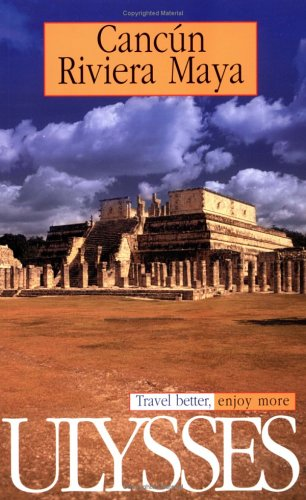Can you describe the historical site shown on the cover of this book? The cover features an image of Chichen Itza, located in the Yucatan Peninsula of Mexico. This significant archaeological site from the Maya civilization is renowned for its monumental architecture and its central pyramid, known as El Castillo. 